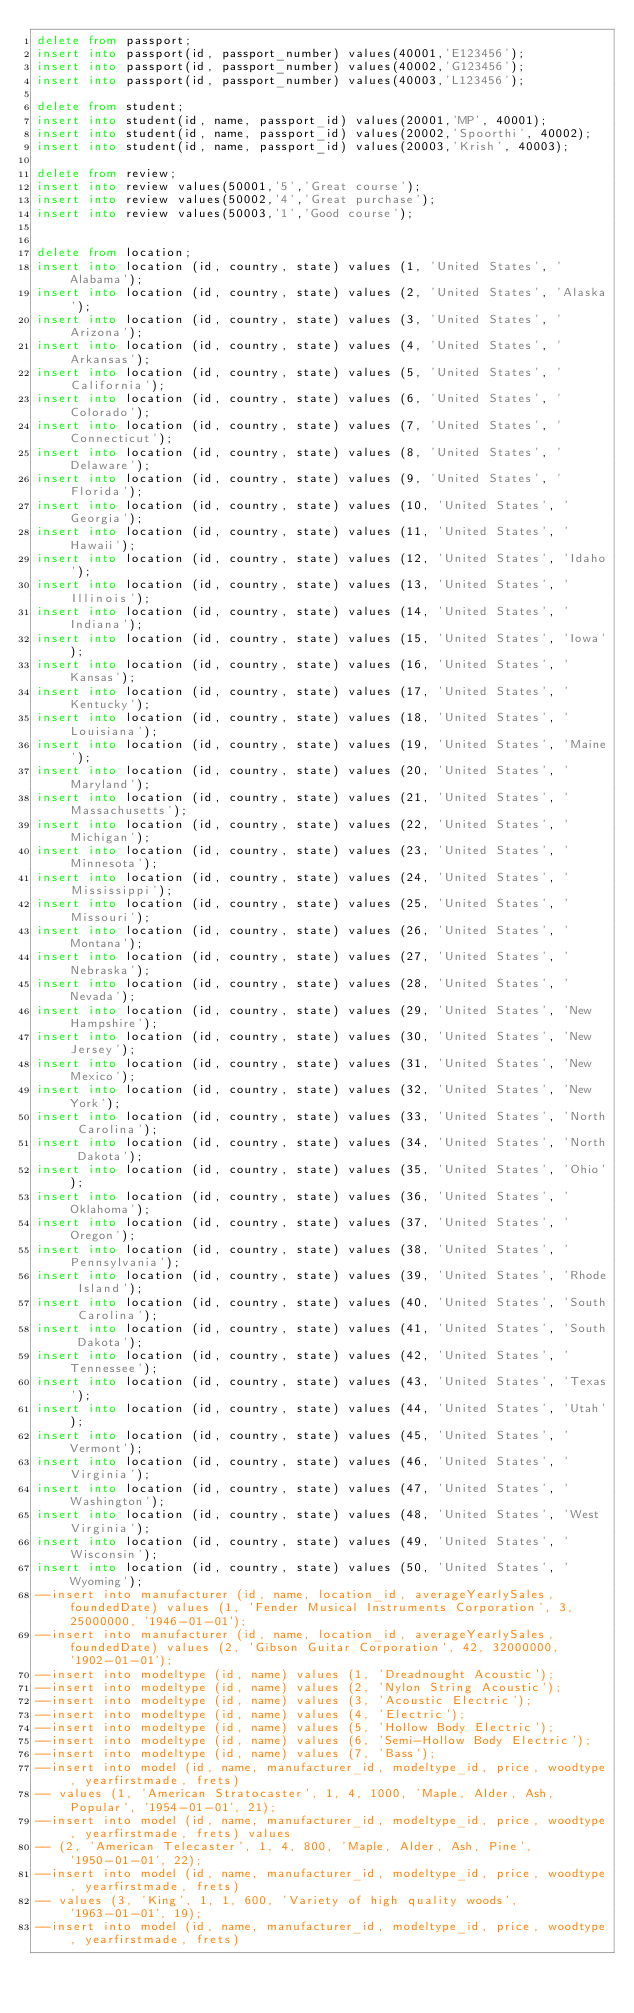<code> <loc_0><loc_0><loc_500><loc_500><_SQL_>delete from passport;
insert into passport(id, passport_number) values(40001,'E123456');
insert into passport(id, passport_number) values(40002,'G123456');
insert into passport(id, passport_number) values(40003,'L123456');

delete from student;
insert into student(id, name, passport_id) values(20001,'MP', 40001);
insert into student(id, name, passport_id) values(20002,'Spoorthi', 40002);
insert into student(id, name, passport_id) values(20003,'Krish', 40003);

delete from review;
insert into review values(50001,'5','Great course');
insert into review values(50002,'4','Great purchase');
insert into review values(50003,'1','Good course');


delete from location;
insert into location (id, country, state) values (1, 'United States', 'Alabama');
insert into location (id, country, state) values (2, 'United States', 'Alaska');
insert into location (id, country, state) values (3, 'United States', 'Arizona');
insert into location (id, country, state) values (4, 'United States', 'Arkansas');
insert into location (id, country, state) values (5, 'United States', 'California');
insert into location (id, country, state) values (6, 'United States', 'Colorado');
insert into location (id, country, state) values (7, 'United States', 'Connecticut');
insert into location (id, country, state) values (8, 'United States', 'Delaware');
insert into location (id, country, state) values (9, 'United States', 'Florida');
insert into location (id, country, state) values (10, 'United States', 'Georgia');
insert into location (id, country, state) values (11, 'United States', 'Hawaii');
insert into location (id, country, state) values (12, 'United States', 'Idaho');
insert into location (id, country, state) values (13, 'United States', 'Illinois');
insert into location (id, country, state) values (14, 'United States', 'Indiana');
insert into location (id, country, state) values (15, 'United States', 'Iowa');
insert into location (id, country, state) values (16, 'United States', 'Kansas');
insert into location (id, country, state) values (17, 'United States', 'Kentucky');
insert into location (id, country, state) values (18, 'United States', 'Louisiana');
insert into location (id, country, state) values (19, 'United States', 'Maine');
insert into location (id, country, state) values (20, 'United States', 'Maryland');
insert into location (id, country, state) values (21, 'United States', 'Massachusetts');
insert into location (id, country, state) values (22, 'United States', 'Michigan');
insert into location (id, country, state) values (23, 'United States', 'Minnesota');
insert into location (id, country, state) values (24, 'United States', 'Mississippi');
insert into location (id, country, state) values (25, 'United States', 'Missouri');
insert into location (id, country, state) values (26, 'United States', 'Montana');
insert into location (id, country, state) values (27, 'United States', 'Nebraska');
insert into location (id, country, state) values (28, 'United States', 'Nevada');
insert into location (id, country, state) values (29, 'United States', 'New Hampshire');
insert into location (id, country, state) values (30, 'United States', 'New Jersey');
insert into location (id, country, state) values (31, 'United States', 'New Mexico');
insert into location (id, country, state) values (32, 'United States', 'New York');
insert into location (id, country, state) values (33, 'United States', 'North Carolina');
insert into location (id, country, state) values (34, 'United States', 'North Dakota');
insert into location (id, country, state) values (35, 'United States', 'Ohio');
insert into location (id, country, state) values (36, 'United States', 'Oklahoma');
insert into location (id, country, state) values (37, 'United States', 'Oregon');
insert into location (id, country, state) values (38, 'United States', 'Pennsylvania');
insert into location (id, country, state) values (39, 'United States', 'Rhode Island');
insert into location (id, country, state) values (40, 'United States', 'South Carolina');
insert into location (id, country, state) values (41, 'United States', 'South Dakota');
insert into location (id, country, state) values (42, 'United States', 'Tennessee');
insert into location (id, country, state) values (43, 'United States', 'Texas');
insert into location (id, country, state) values (44, 'United States', 'Utah');
insert into location (id, country, state) values (45, 'United States', 'Vermont');
insert into location (id, country, state) values (46, 'United States', 'Virginia');
insert into location (id, country, state) values (47, 'United States', 'Washington');
insert into location (id, country, state) values (48, 'United States', 'West Virginia');
insert into location (id, country, state) values (49, 'United States', 'Wisconsin');
insert into location (id, country, state) values (50, 'United States', 'Wyoming');
--insert into manufacturer (id, name, location_id, averageYearlySales, foundedDate) values (1, 'Fender Musical Instruments Corporation', 3, 25000000, '1946-01-01');
--insert into manufacturer (id, name, location_id, averageYearlySales, foundedDate) values (2, 'Gibson Guitar Corporation', 42, 32000000, '1902-01-01');
--insert into modeltype (id, name) values (1, 'Dreadnought Acoustic');
--insert into modeltype (id, name) values (2, 'Nylon String Acoustic');
--insert into modeltype (id, name) values (3, 'Acoustic Electric');
--insert into modeltype (id, name) values (4, 'Electric');
--insert into modeltype (id, name) values (5, 'Hollow Body Electric');
--insert into modeltype (id, name) values (6, 'Semi-Hollow Body Electric');
--insert into modeltype (id, name) values (7, 'Bass');
--insert into model (id, name, manufacturer_id, modeltype_id, price, woodtype, yearfirstmade, frets)
-- values (1, 'American Stratocaster', 1, 4, 1000, 'Maple, Alder, Ash, Popular', '1954-01-01', 21);
--insert into model (id, name, manufacturer_id, modeltype_id, price, woodtype, yearfirstmade, frets) values
-- (2, 'American Telecaster', 1, 4, 800, 'Maple, Alder, Ash, Pine', '1950-01-01', 22);
--insert into model (id, name, manufacturer_id, modeltype_id, price, woodtype, yearfirstmade, frets)
-- values (3, 'King', 1, 1, 600, 'Variety of high quality woods', '1963-01-01', 19);
--insert into model (id, name, manufacturer_id, modeltype_id, price, woodtype, yearfirstmade, frets)</code> 